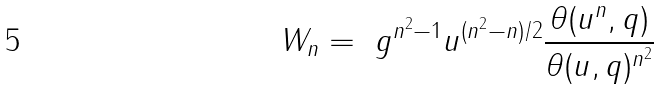Convert formula to latex. <formula><loc_0><loc_0><loc_500><loc_500>W _ { n } = \ g ^ { n ^ { 2 } - 1 } u ^ { ( n ^ { 2 } - n ) / 2 } \frac { \theta ( u ^ { n } , q ) } { \theta ( u , q ) ^ { n ^ { 2 } } }</formula> 